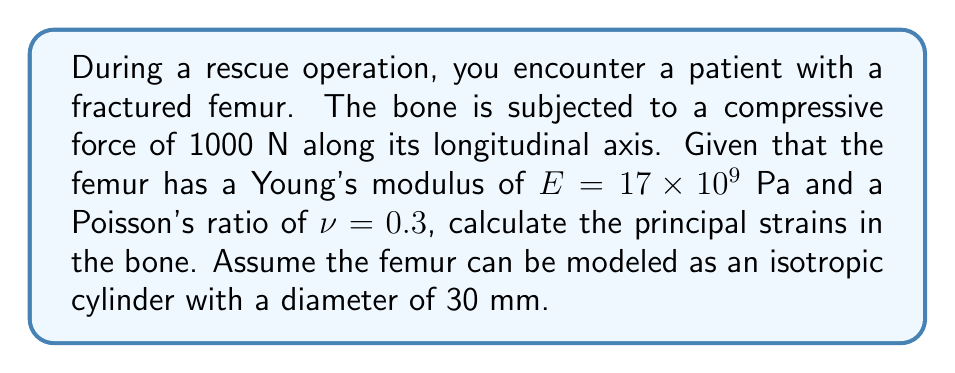Can you solve this math problem? To solve this problem, we'll use the concepts of stress and strain tensors in cylindrical coordinates:

1. Calculate the stress:
   The stress $\sigma$ is given by force divided by area.
   $$\sigma = \frac{F}{A} = \frac{1000 \text{ N}}{\pi (0.015 \text{ m})^2} = 1.41 \times 10^6 \text{ Pa}$$

2. For an isotropic material under uniaxial stress, the strain tensor in cylindrical coordinates $(r, \theta, z)$ is:
   $$\varepsilon = \begin{bmatrix}
   \varepsilon_{rr} & 0 & 0 \\
   0 & \varepsilon_{\theta\theta} & 0 \\
   0 & 0 & \varepsilon_{zz}
   \end{bmatrix}$$

3. The principal strains are:
   $$\varepsilon_{zz} = \frac{\sigma}{E}$$
   $$\varepsilon_{rr} = \varepsilon_{\theta\theta} = -\nu\varepsilon_{zz}$$

4. Calculate $\varepsilon_{zz}$:
   $$\varepsilon_{zz} = \frac{1.41 \times 10^6 \text{ Pa}}{17 \times 10^9 \text{ Pa}} = 8.29 \times 10^{-5}$$

5. Calculate $\varepsilon_{rr}$ and $\varepsilon_{\theta\theta}$:
   $$\varepsilon_{rr} = \varepsilon_{\theta\theta} = -0.3 \times (8.29 \times 10^{-5}) = -2.49 \times 10^{-5}$$

Therefore, the principal strains are:
$\varepsilon_{zz} = 8.29 \times 10^{-5}$ (longitudinal strain)
$\varepsilon_{rr} = \varepsilon_{\theta\theta} = -2.49 \times 10^{-5}$ (radial and circumferential strains)
Answer: $\varepsilon_{zz} = 8.29 \times 10^{-5}$, $\varepsilon_{rr} = \varepsilon_{\theta\theta} = -2.49 \times 10^{-5}$ 